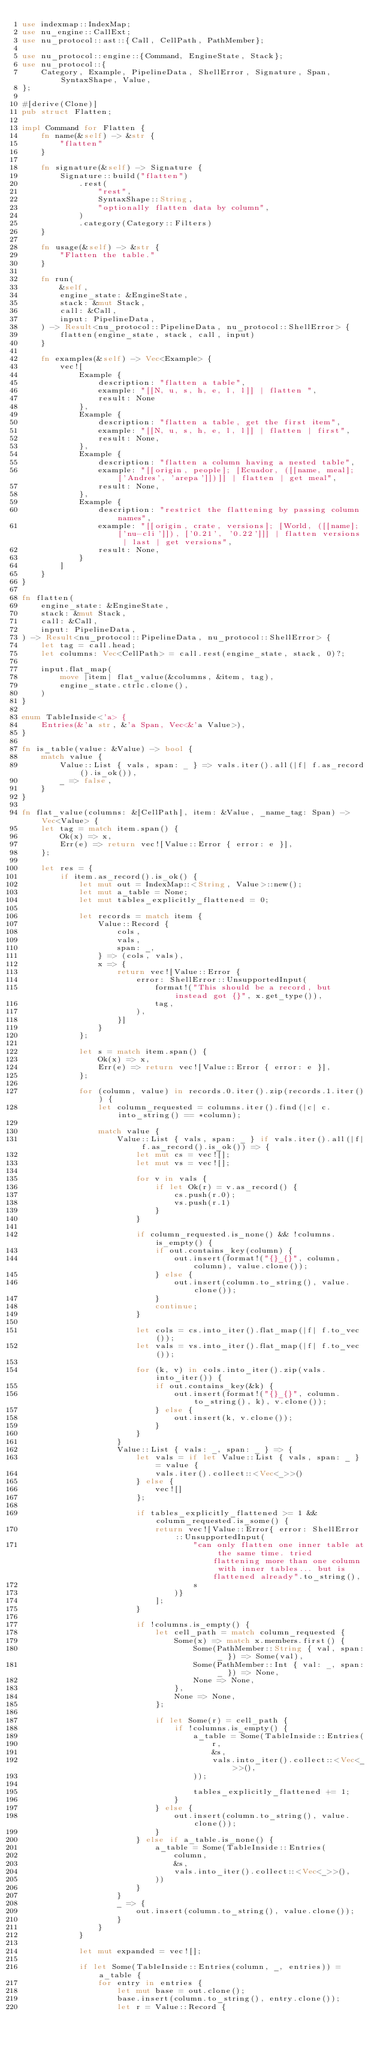<code> <loc_0><loc_0><loc_500><loc_500><_Rust_>use indexmap::IndexMap;
use nu_engine::CallExt;
use nu_protocol::ast::{Call, CellPath, PathMember};

use nu_protocol::engine::{Command, EngineState, Stack};
use nu_protocol::{
    Category, Example, PipelineData, ShellError, Signature, Span, SyntaxShape, Value,
};

#[derive(Clone)]
pub struct Flatten;

impl Command for Flatten {
    fn name(&self) -> &str {
        "flatten"
    }

    fn signature(&self) -> Signature {
        Signature::build("flatten")
            .rest(
                "rest",
                SyntaxShape::String,
                "optionally flatten data by column",
            )
            .category(Category::Filters)
    }

    fn usage(&self) -> &str {
        "Flatten the table."
    }

    fn run(
        &self,
        engine_state: &EngineState,
        stack: &mut Stack,
        call: &Call,
        input: PipelineData,
    ) -> Result<nu_protocol::PipelineData, nu_protocol::ShellError> {
        flatten(engine_state, stack, call, input)
    }

    fn examples(&self) -> Vec<Example> {
        vec![
            Example {
                description: "flatten a table",
                example: "[[N, u, s, h, e, l, l]] | flatten ",
                result: None
            },
            Example {
                description: "flatten a table, get the first item",
                example: "[[N, u, s, h, e, l, l]] | flatten | first",
                result: None,
            },
            Example {
                description: "flatten a column having a nested table",
                example: "[[origin, people]; [Ecuador, ([[name, meal]; ['Andres', 'arepa']])]] | flatten | get meal",
                result: None,
            },
            Example {
                description: "restrict the flattening by passing column names",
                example: "[[origin, crate, versions]; [World, ([[name]; ['nu-cli']]), ['0.21', '0.22']]] | flatten versions | last | get versions",
                result: None,
            }
        ]
    }
}

fn flatten(
    engine_state: &EngineState,
    stack: &mut Stack,
    call: &Call,
    input: PipelineData,
) -> Result<nu_protocol::PipelineData, nu_protocol::ShellError> {
    let tag = call.head;
    let columns: Vec<CellPath> = call.rest(engine_state, stack, 0)?;

    input.flat_map(
        move |item| flat_value(&columns, &item, tag),
        engine_state.ctrlc.clone(),
    )
}

enum TableInside<'a> {
    Entries(&'a str, &'a Span, Vec<&'a Value>),
}

fn is_table(value: &Value) -> bool {
    match value {
        Value::List { vals, span: _ } => vals.iter().all(|f| f.as_record().is_ok()),
        _ => false,
    }
}

fn flat_value(columns: &[CellPath], item: &Value, _name_tag: Span) -> Vec<Value> {
    let tag = match item.span() {
        Ok(x) => x,
        Err(e) => return vec![Value::Error { error: e }],
    };

    let res = {
        if item.as_record().is_ok() {
            let mut out = IndexMap::<String, Value>::new();
            let mut a_table = None;
            let mut tables_explicitly_flattened = 0;

            let records = match item {
                Value::Record {
                    cols,
                    vals,
                    span: _,
                } => (cols, vals),
                x => {
                    return vec![Value::Error {
                        error: ShellError::UnsupportedInput(
                            format!("This should be a record, but instead got {}", x.get_type()),
                            tag,
                        ),
                    }]
                }
            };

            let s = match item.span() {
                Ok(x) => x,
                Err(e) => return vec![Value::Error { error: e }],
            };

            for (column, value) in records.0.iter().zip(records.1.iter()) {
                let column_requested = columns.iter().find(|c| c.into_string() == *column);

                match value {
                    Value::List { vals, span: _ } if vals.iter().all(|f| f.as_record().is_ok()) => {
                        let mut cs = vec![];
                        let mut vs = vec![];

                        for v in vals {
                            if let Ok(r) = v.as_record() {
                                cs.push(r.0);
                                vs.push(r.1)
                            }
                        }

                        if column_requested.is_none() && !columns.is_empty() {
                            if out.contains_key(column) {
                                out.insert(format!("{}_{}", column, column), value.clone());
                            } else {
                                out.insert(column.to_string(), value.clone());
                            }
                            continue;
                        }

                        let cols = cs.into_iter().flat_map(|f| f.to_vec());
                        let vals = vs.into_iter().flat_map(|f| f.to_vec());

                        for (k, v) in cols.into_iter().zip(vals.into_iter()) {
                            if out.contains_key(&k) {
                                out.insert(format!("{}_{}", column.to_string(), k), v.clone());
                            } else {
                                out.insert(k, v.clone());
                            }
                        }
                    }
                    Value::List { vals: _, span: _ } => {
                        let vals = if let Value::List { vals, span: _ } = value {
                            vals.iter().collect::<Vec<_>>()
                        } else {
                            vec![]
                        };

                        if tables_explicitly_flattened >= 1 && column_requested.is_some() {
                            return vec![Value::Error{ error: ShellError::UnsupportedInput(
                                    "can only flatten one inner table at the same time. tried flattening more than one column with inner tables... but is flattened already".to_string(),
                                    s
                                )}
                            ];
                        }

                        if !columns.is_empty() {
                            let cell_path = match column_requested {
                                Some(x) => match x.members.first() {
                                    Some(PathMember::String { val, span: _ }) => Some(val),
                                    Some(PathMember::Int { val: _, span: _ }) => None,
                                    None => None,
                                },
                                None => None,
                            };

                            if let Some(r) = cell_path {
                                if !columns.is_empty() {
                                    a_table = Some(TableInside::Entries(
                                        r,
                                        &s,
                                        vals.into_iter().collect::<Vec<_>>(),
                                    ));

                                    tables_explicitly_flattened += 1;
                                }
                            } else {
                                out.insert(column.to_string(), value.clone());
                            }
                        } else if a_table.is_none() {
                            a_table = Some(TableInside::Entries(
                                column,
                                &s,
                                vals.into_iter().collect::<Vec<_>>(),
                            ))
                        }
                    }
                    _ => {
                        out.insert(column.to_string(), value.clone());
                    }
                }
            }

            let mut expanded = vec![];

            if let Some(TableInside::Entries(column, _, entries)) = a_table {
                for entry in entries {
                    let mut base = out.clone();
                    base.insert(column.to_string(), entry.clone());
                    let r = Value::Record {</code> 